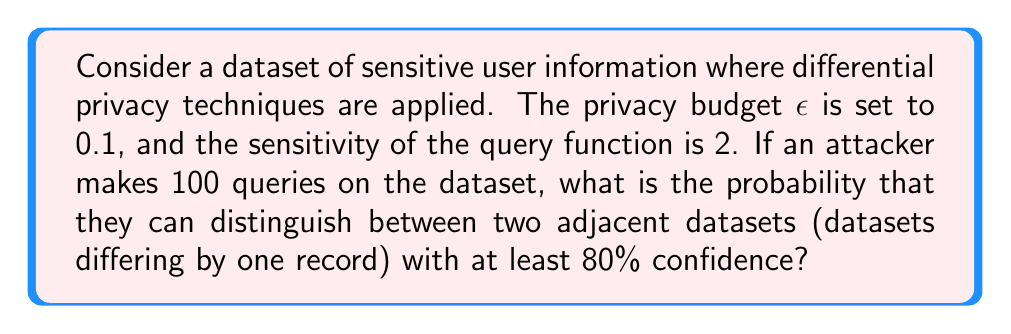Give your solution to this math problem. To solve this problem, we need to understand the principles of differential privacy and how it relates to the given scenario. Let's break it down step-by-step:

1. Differential Privacy Guarantee:
   The fundamental guarantee of differential privacy is that the probability of any output occurring is at most $e^\epsilon$ times as likely with one dataset as with an adjacent dataset.

2. Composition Theorem:
   When multiple queries are made, the privacy guarantees compose additively. For 100 queries, the effective epsilon becomes $100 \times 0.1 = 10$.

3. Sensitivity and Noise:
   The sensitivity of 2 means that changing one record can change the query result by at most 2. To achieve differential privacy, we add noise drawn from a Laplace distribution with scale $\frac{2}{\epsilon} = \frac{2}{0.1} = 20$.

4. Distinguishability:
   For an attacker to distinguish between two adjacent datasets with 80% confidence, the difference in query results must be greater than the noise with probability 0.8.

5. Probability Calculation:
   Let $X$ be the random variable representing the noise. We need to find $P(|X| < d)$, where $d$ is the distinguishability threshold.

   For Laplace distribution: $P(|X| < d) = 1 - e^{-\frac{d}{b}}$, where $b$ is the scale parameter.

   Setting this equal to 0.8: $1 - e^{-\frac{d}{20}} = 0.8$

6. Solving for d:
   $e^{-\frac{d}{20}} = 0.2$
   $-\frac{d}{20} = \ln(0.2)$
   $d = -20 \ln(0.2) \approx 32.19$

7. Final Probability:
   The probability that the attacker can distinguish between datasets is the probability that the actual difference (2) is greater than this threshold (32.19).

   $P(\text{distinguish}) = P(2 > 32.19) = 0$
Answer: The probability that an attacker can distinguish between two adjacent datasets with at least 80% confidence after 100 queries is 0. 